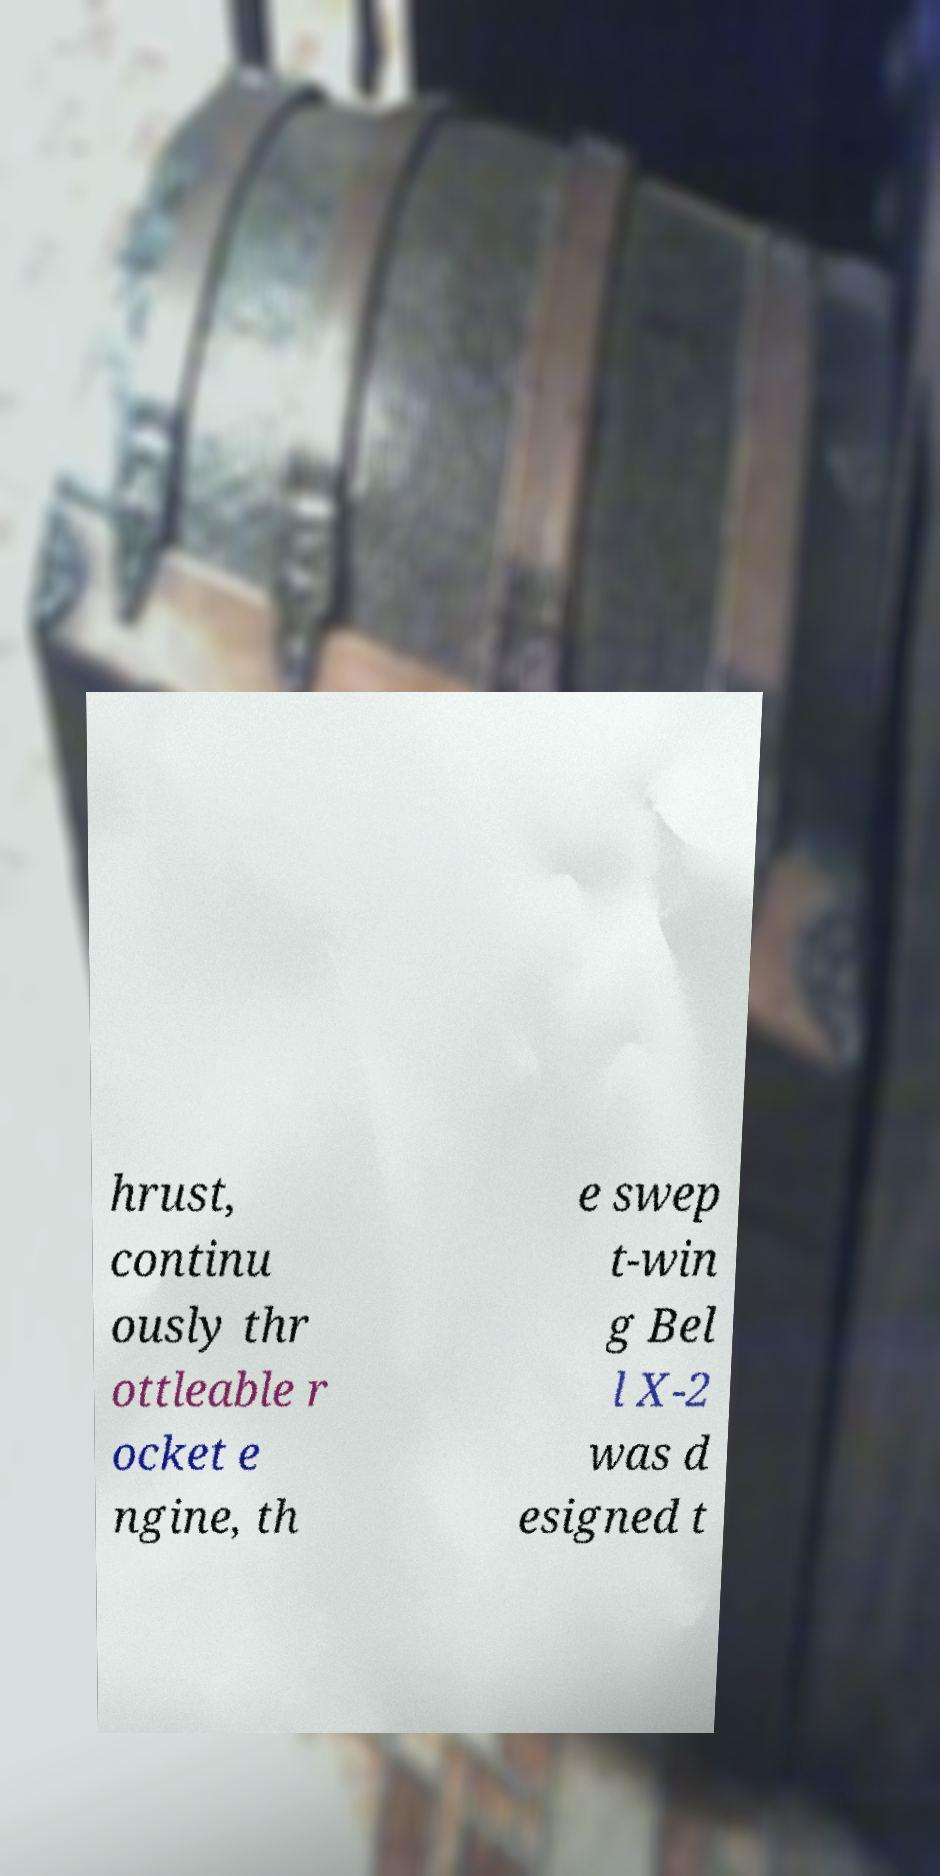For documentation purposes, I need the text within this image transcribed. Could you provide that? hrust, continu ously thr ottleable r ocket e ngine, th e swep t-win g Bel l X-2 was d esigned t 